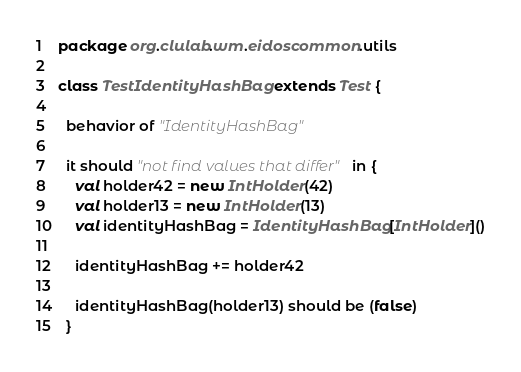<code> <loc_0><loc_0><loc_500><loc_500><_Scala_>package org.clulab.wm.eidoscommon.utils

class TestIdentityHashBag extends Test {

  behavior of "IdentityHashBag"

  it should "not find values that differ" in {
    val holder42 = new IntHolder(42)
    val holder13 = new IntHolder(13)
    val identityHashBag = IdentityHashBag[IntHolder]()

    identityHashBag += holder42

    identityHashBag(holder13) should be (false)
  }
</code> 